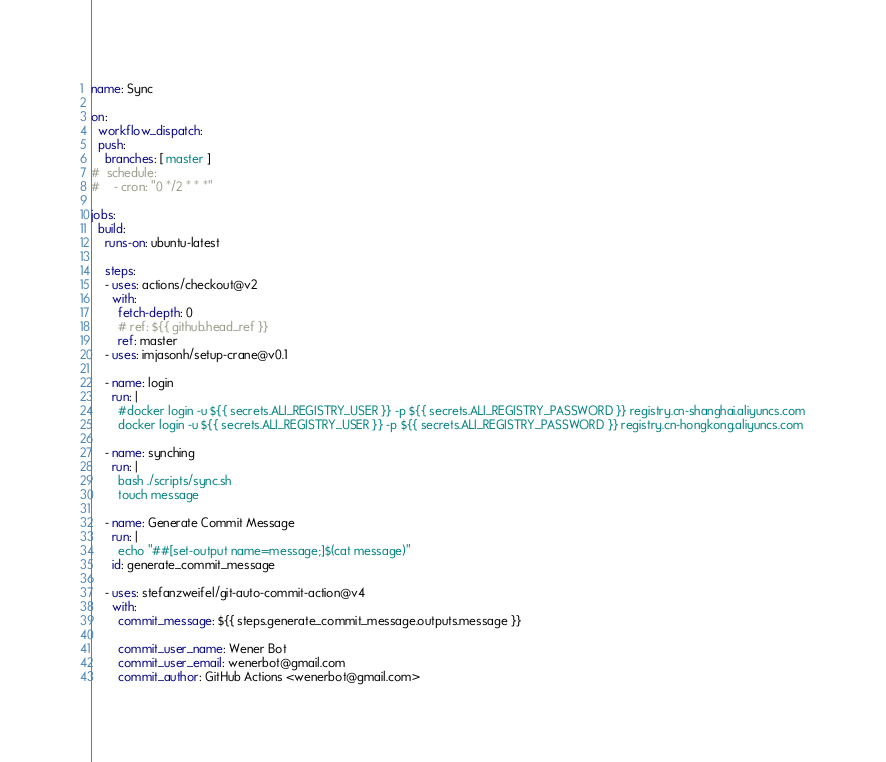<code> <loc_0><loc_0><loc_500><loc_500><_YAML_>name: Sync

on:
  workflow_dispatch:
  push:
    branches: [ master ]
#  schedule:
#    - cron: "0 */2 * * *"

jobs:
  build:
    runs-on: ubuntu-latest

    steps:
    - uses: actions/checkout@v2
      with:
        fetch-depth: 0
        # ref: ${{ github.head_ref }}
        ref: master
    - uses: imjasonh/setup-crane@v0.1

    - name: login
      run: |
        #docker login -u ${{ secrets.ALI_REGISTRY_USER }} -p ${{ secrets.ALI_REGISTRY_PASSWORD }} registry.cn-shanghai.aliyuncs.com
        docker login -u ${{ secrets.ALI_REGISTRY_USER }} -p ${{ secrets.ALI_REGISTRY_PASSWORD }} registry.cn-hongkong.aliyuncs.com

    - name: synching
      run: |
        bash ./scripts/sync.sh
        touch message

    - name: Generate Commit Message
      run: |
        echo "##[set-output name=message;]$(cat message)"
      id: generate_commit_message

    - uses: stefanzweifel/git-auto-commit-action@v4
      with:
        commit_message: ${{ steps.generate_commit_message.outputs.message }}

        commit_user_name: Wener Bot
        commit_user_email: wenerbot@gmail.com
        commit_author: GitHub Actions <wenerbot@gmail.com>
</code> 